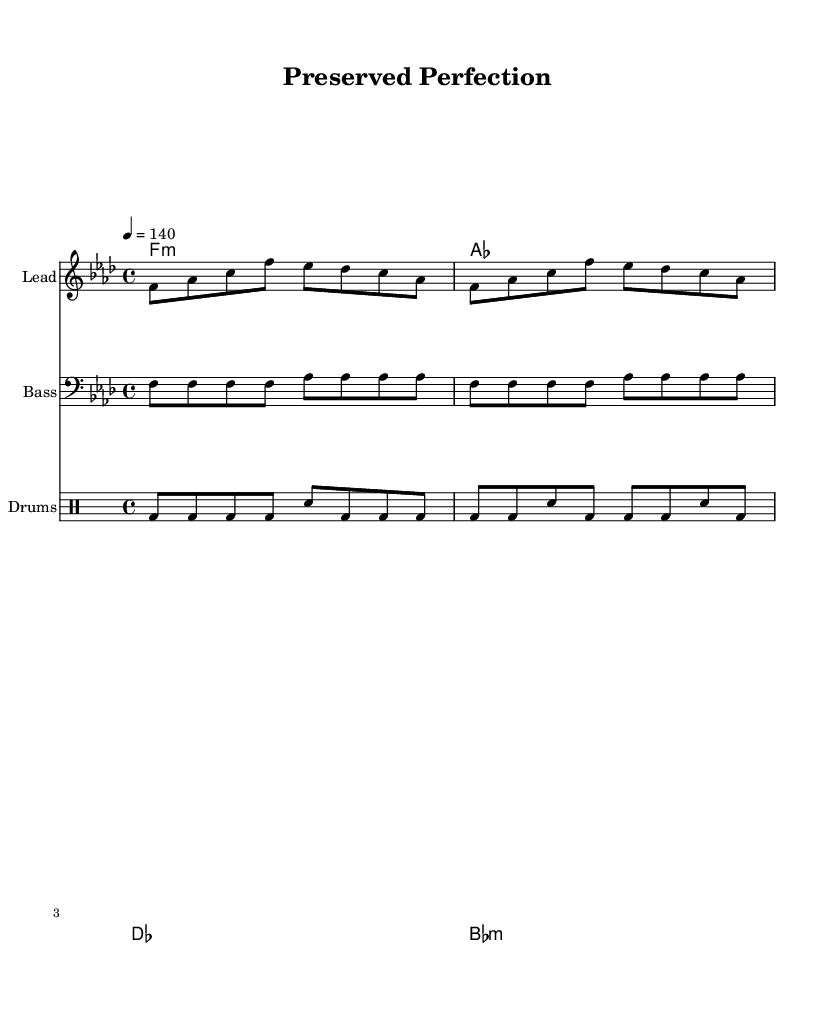what is the key signature of this music? The key signature indicates that the music is in F minor, which consists of four flats: B♭, E♭, A♭, and D♭. This can be identified in the sheet music on the left side where the key signature is notated.
Answer: F minor what is the time signature of this music? The time signature is indicated at the beginning of the sheet music, where it shows 4/4, meaning there are four beats in each measure and the quarter note gets one beat.
Answer: 4/4 what is the tempo marking of this piece? The tempo marking is specified in the score as "4 = 140," indicating that there are 140 beats per minute, which is a common pace for Trap music. This tells performers how fast to play the piece.
Answer: 140 how many measures are in the melody section? The melody section consists of 8 measures, based on the number of phrases and the segments of music written in the staff, where each segment typically corresponds to a measure.
Answer: 8 what style of music is reflected in the title? The title "Preserved Perfection" suggests a blend of themes from both Trap music and artful taxidermy, celebrating the beauty of taxidermy through hip-hop culture, which is a significant influence in Trap music.
Answer: Trap what instruments are included in this score? The score includes three types of instruments: a lead instrument (typically for melody), bass (for low frequencies), and drums (for rhythm). Each is written on separate staves for clarity in performance.
Answer: Lead, Bass, Drums how does the bass part interact with the melody? The bass part provides a rhythmic and harmonic foundation by syncing with the melody, often doubling or complementing the melody's rhythm, which creates depth and groove characteristic of Trap music.
Answer: It complements 